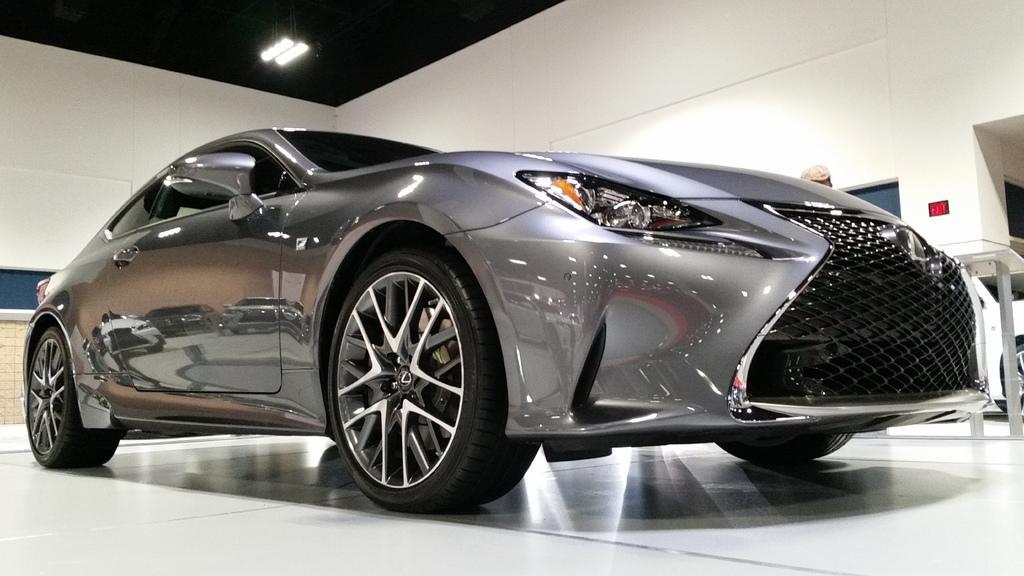Can you describe this image briefly? This is an inside view. Here I can see a car on the floor which is facing towards the right side. On the right side I can see another car and also there is a table. In the background I can see the walls. On the top there are two lights. 